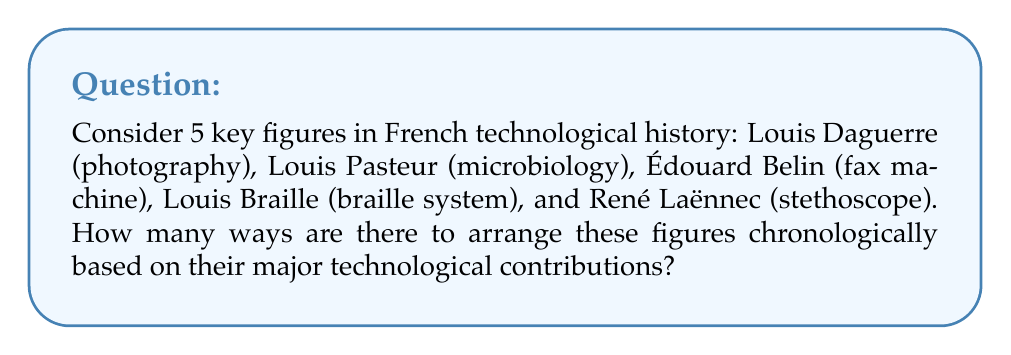Can you answer this question? To solve this problem, we need to use the concept of permutations from combinatorics. Since we are arranging all 5 figures in a specific order (chronologically), this is a straightforward permutation problem.

The number of ways to arrange n distinct objects is given by the factorial of n, denoted as n!

In this case:
1. We have 5 key figures to arrange.
2. The formula for permutations is: $P(n) = n!$
3. Therefore, the number of ways to arrange 5 figures is: $P(5) = 5!$

Let's calculate 5!:

$$
\begin{align}
5! &= 5 \times 4 \times 3 \times 2 \times 1 \\
&= 120
\end{align}
$$

Thus, there are 120 possible ways to arrange these 5 key figures in French technological history chronologically.

Note: This calculation assumes that we don't know the actual chronological order of their contributions. In reality, there is only one correct chronological order, but from a combinatorial perspective, we consider all possible arrangements.
Answer: $120$ 